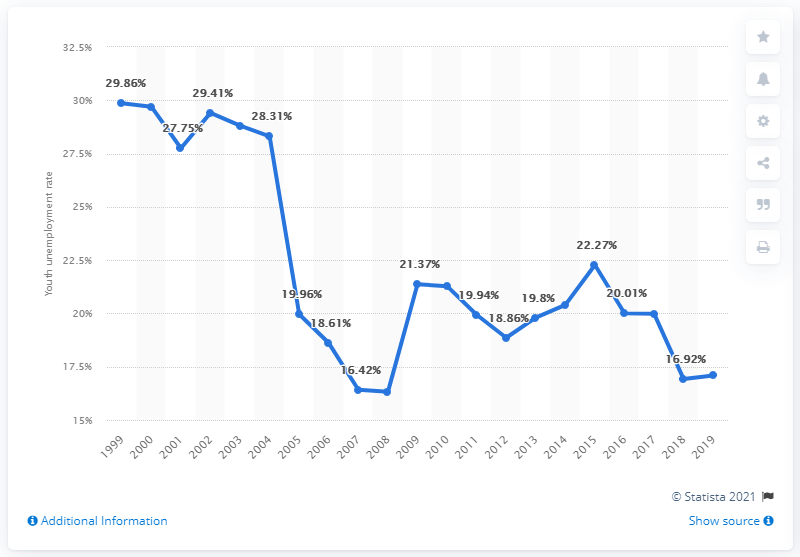Give some essential details in this illustration. In 2019, the youth unemployment rate in Finland was 17.09 percent. 